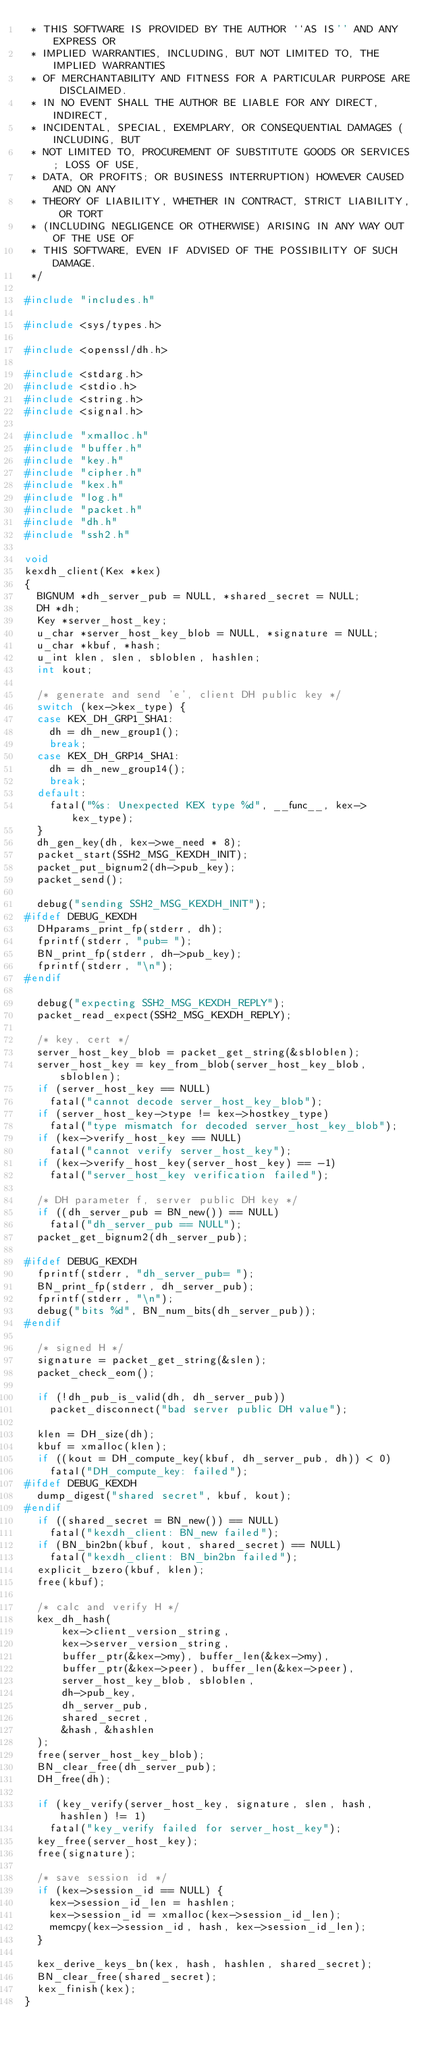Convert code to text. <code><loc_0><loc_0><loc_500><loc_500><_C_> * THIS SOFTWARE IS PROVIDED BY THE AUTHOR ``AS IS'' AND ANY EXPRESS OR
 * IMPLIED WARRANTIES, INCLUDING, BUT NOT LIMITED TO, THE IMPLIED WARRANTIES
 * OF MERCHANTABILITY AND FITNESS FOR A PARTICULAR PURPOSE ARE DISCLAIMED.
 * IN NO EVENT SHALL THE AUTHOR BE LIABLE FOR ANY DIRECT, INDIRECT,
 * INCIDENTAL, SPECIAL, EXEMPLARY, OR CONSEQUENTIAL DAMAGES (INCLUDING, BUT
 * NOT LIMITED TO, PROCUREMENT OF SUBSTITUTE GOODS OR SERVICES; LOSS OF USE,
 * DATA, OR PROFITS; OR BUSINESS INTERRUPTION) HOWEVER CAUSED AND ON ANY
 * THEORY OF LIABILITY, WHETHER IN CONTRACT, STRICT LIABILITY, OR TORT
 * (INCLUDING NEGLIGENCE OR OTHERWISE) ARISING IN ANY WAY OUT OF THE USE OF
 * THIS SOFTWARE, EVEN IF ADVISED OF THE POSSIBILITY OF SUCH DAMAGE.
 */

#include "includes.h"

#include <sys/types.h>

#include <openssl/dh.h>

#include <stdarg.h>
#include <stdio.h>
#include <string.h>
#include <signal.h>

#include "xmalloc.h"
#include "buffer.h"
#include "key.h"
#include "cipher.h"
#include "kex.h"
#include "log.h"
#include "packet.h"
#include "dh.h"
#include "ssh2.h"

void
kexdh_client(Kex *kex)
{
	BIGNUM *dh_server_pub = NULL, *shared_secret = NULL;
	DH *dh;
	Key *server_host_key;
	u_char *server_host_key_blob = NULL, *signature = NULL;
	u_char *kbuf, *hash;
	u_int klen, slen, sbloblen, hashlen;
	int kout;

	/* generate and send 'e', client DH public key */
	switch (kex->kex_type) {
	case KEX_DH_GRP1_SHA1:
		dh = dh_new_group1();
		break;
	case KEX_DH_GRP14_SHA1:
		dh = dh_new_group14();
		break;
	default:
		fatal("%s: Unexpected KEX type %d", __func__, kex->kex_type);
	}
	dh_gen_key(dh, kex->we_need * 8);
	packet_start(SSH2_MSG_KEXDH_INIT);
	packet_put_bignum2(dh->pub_key);
	packet_send();

	debug("sending SSH2_MSG_KEXDH_INIT");
#ifdef DEBUG_KEXDH
	DHparams_print_fp(stderr, dh);
	fprintf(stderr, "pub= ");
	BN_print_fp(stderr, dh->pub_key);
	fprintf(stderr, "\n");
#endif

	debug("expecting SSH2_MSG_KEXDH_REPLY");
	packet_read_expect(SSH2_MSG_KEXDH_REPLY);

	/* key, cert */
	server_host_key_blob = packet_get_string(&sbloblen);
	server_host_key = key_from_blob(server_host_key_blob, sbloblen);
	if (server_host_key == NULL)
		fatal("cannot decode server_host_key_blob");
	if (server_host_key->type != kex->hostkey_type)
		fatal("type mismatch for decoded server_host_key_blob");
	if (kex->verify_host_key == NULL)
		fatal("cannot verify server_host_key");
	if (kex->verify_host_key(server_host_key) == -1)
		fatal("server_host_key verification failed");

	/* DH parameter f, server public DH key */
	if ((dh_server_pub = BN_new()) == NULL)
		fatal("dh_server_pub == NULL");
	packet_get_bignum2(dh_server_pub);

#ifdef DEBUG_KEXDH
	fprintf(stderr, "dh_server_pub= ");
	BN_print_fp(stderr, dh_server_pub);
	fprintf(stderr, "\n");
	debug("bits %d", BN_num_bits(dh_server_pub));
#endif

	/* signed H */
	signature = packet_get_string(&slen);
	packet_check_eom();

	if (!dh_pub_is_valid(dh, dh_server_pub))
		packet_disconnect("bad server public DH value");

	klen = DH_size(dh);
	kbuf = xmalloc(klen);
	if ((kout = DH_compute_key(kbuf, dh_server_pub, dh)) < 0)
		fatal("DH_compute_key: failed");
#ifdef DEBUG_KEXDH
	dump_digest("shared secret", kbuf, kout);
#endif
	if ((shared_secret = BN_new()) == NULL)
		fatal("kexdh_client: BN_new failed");
	if (BN_bin2bn(kbuf, kout, shared_secret) == NULL)
		fatal("kexdh_client: BN_bin2bn failed");
	explicit_bzero(kbuf, klen);
	free(kbuf);

	/* calc and verify H */
	kex_dh_hash(
	    kex->client_version_string,
	    kex->server_version_string,
	    buffer_ptr(&kex->my), buffer_len(&kex->my),
	    buffer_ptr(&kex->peer), buffer_len(&kex->peer),
	    server_host_key_blob, sbloblen,
	    dh->pub_key,
	    dh_server_pub,
	    shared_secret,
	    &hash, &hashlen
	);
	free(server_host_key_blob);
	BN_clear_free(dh_server_pub);
	DH_free(dh);

	if (key_verify(server_host_key, signature, slen, hash, hashlen) != 1)
		fatal("key_verify failed for server_host_key");
	key_free(server_host_key);
	free(signature);

	/* save session id */
	if (kex->session_id == NULL) {
		kex->session_id_len = hashlen;
		kex->session_id = xmalloc(kex->session_id_len);
		memcpy(kex->session_id, hash, kex->session_id_len);
	}

	kex_derive_keys_bn(kex, hash, hashlen, shared_secret);
	BN_clear_free(shared_secret);
	kex_finish(kex);
}
</code> 